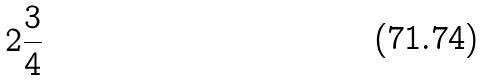<formula> <loc_0><loc_0><loc_500><loc_500>2 \frac { 3 } { 4 }</formula> 